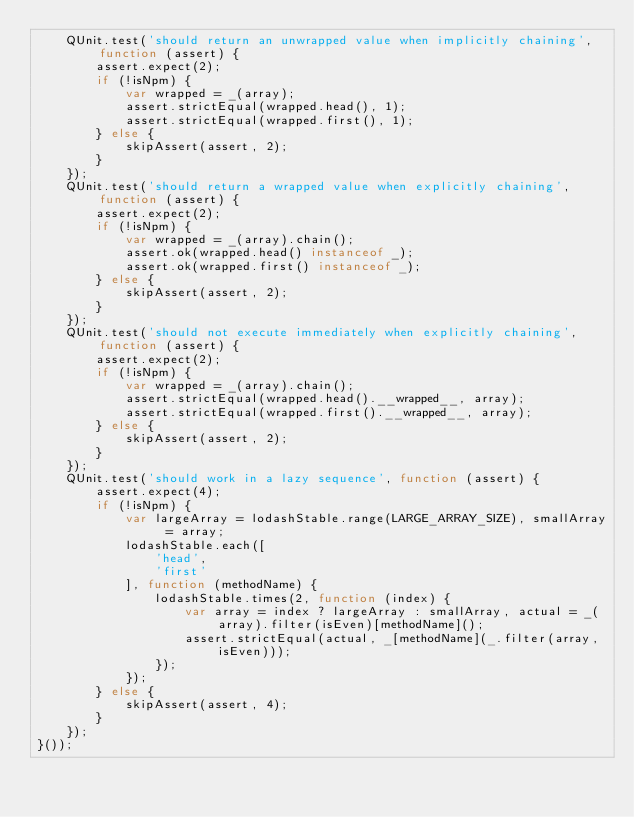<code> <loc_0><loc_0><loc_500><loc_500><_JavaScript_>    QUnit.test('should return an unwrapped value when implicitly chaining', function (assert) {
        assert.expect(2);
        if (!isNpm) {
            var wrapped = _(array);
            assert.strictEqual(wrapped.head(), 1);
            assert.strictEqual(wrapped.first(), 1);
        } else {
            skipAssert(assert, 2);
        }
    });
    QUnit.test('should return a wrapped value when explicitly chaining', function (assert) {
        assert.expect(2);
        if (!isNpm) {
            var wrapped = _(array).chain();
            assert.ok(wrapped.head() instanceof _);
            assert.ok(wrapped.first() instanceof _);
        } else {
            skipAssert(assert, 2);
        }
    });
    QUnit.test('should not execute immediately when explicitly chaining', function (assert) {
        assert.expect(2);
        if (!isNpm) {
            var wrapped = _(array).chain();
            assert.strictEqual(wrapped.head().__wrapped__, array);
            assert.strictEqual(wrapped.first().__wrapped__, array);
        } else {
            skipAssert(assert, 2);
        }
    });
    QUnit.test('should work in a lazy sequence', function (assert) {
        assert.expect(4);
        if (!isNpm) {
            var largeArray = lodashStable.range(LARGE_ARRAY_SIZE), smallArray = array;
            lodashStable.each([
                'head',
                'first'
            ], function (methodName) {
                lodashStable.times(2, function (index) {
                    var array = index ? largeArray : smallArray, actual = _(array).filter(isEven)[methodName]();
                    assert.strictEqual(actual, _[methodName](_.filter(array, isEven)));
                });
            });
        } else {
            skipAssert(assert, 4);
        }
    });
}());</code> 